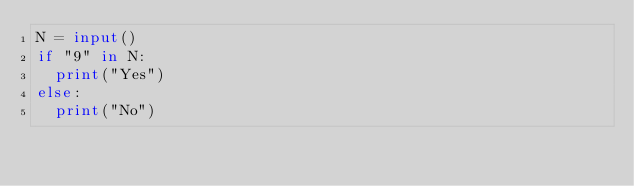Convert code to text. <code><loc_0><loc_0><loc_500><loc_500><_Python_>N = input()
if "9" in N:
  print("Yes")
else:
  print("No")</code> 